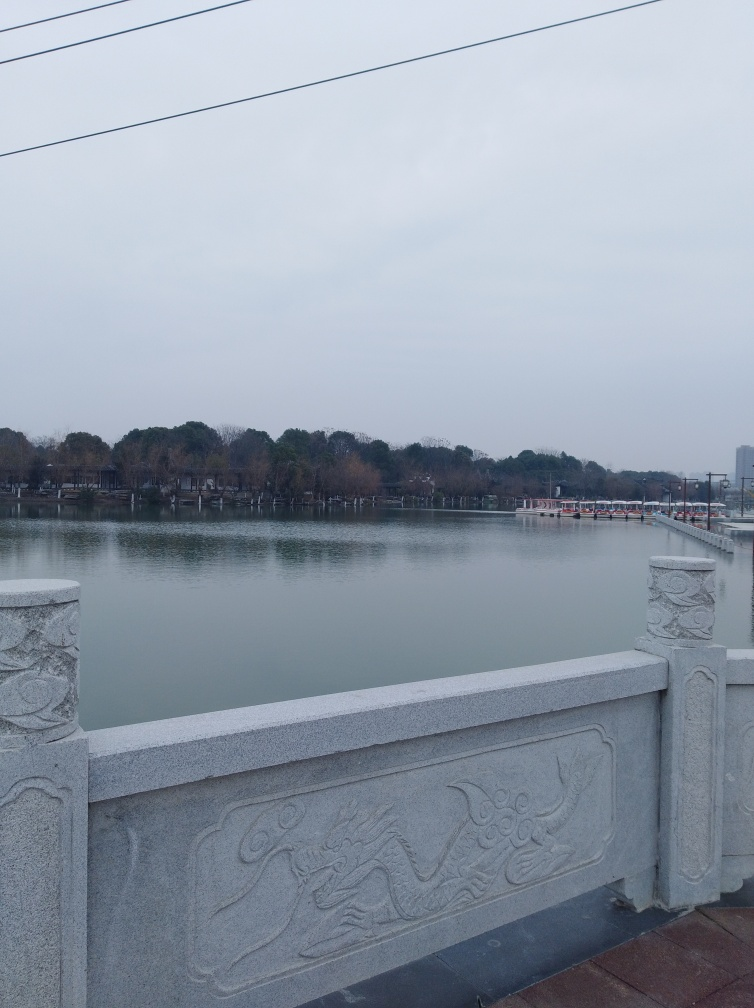What can you tell about the weather in this image? Is it likely to be cold, warm, or neutral? The weather in the image appears to be on the colder side. The overcast sky, absence of shadows, and the overall grayish tone suggest a lack of direct sunlight, which typically indicates cooler temperatures. 